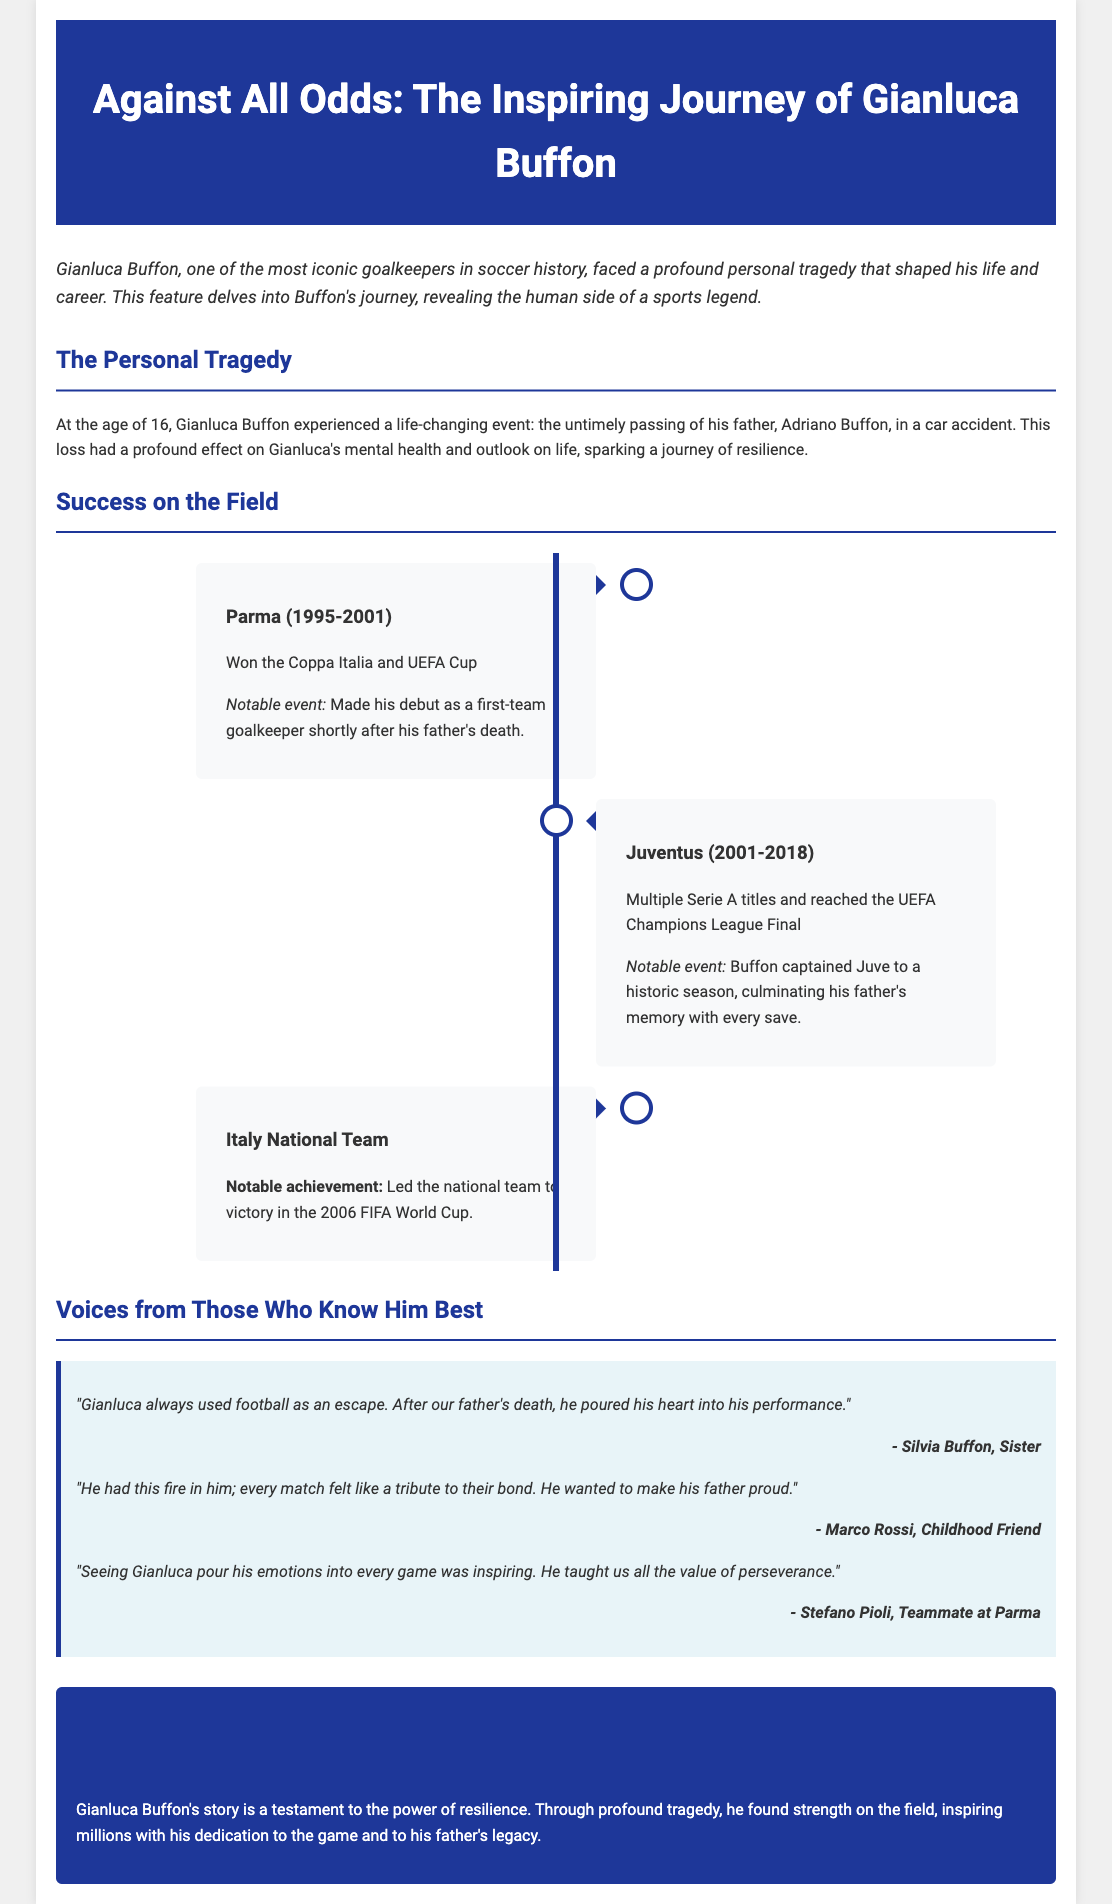what tragedy did Gianluca Buffon face at age 16? The document states that Gianluca Buffon experienced the untimely passing of his father in a car accident.
Answer: his father's death which teams did Gianluca Buffon play for mentioned in the document? The document lists Parma and Juventus as the two major teams where Gianluca played.
Answer: Parma and Juventus what notable achievement did Gianluca Buffon accomplish with the Italy National Team? The document highlights that Gianluca led the national team to victory in the 2006 FIFA World Cup.
Answer: victory in the 2006 FIFA World Cup who is Gianluca Buffon's sister? The document mentions Silvia Buffon as Gianluca's sister providing a quote about him.
Answer: Silvia Buffon what did Marco Rossi say about Gianluca's motivation in games? The document quotes Marco Rossi as saying that Gianluca wanted to make his father proud in every match.
Answer: make his father proud how long did Gianluca Buffon play for Juventus? The document states that he played for Juventus from 2001 to 2018, which is 17 years.
Answer: 17 years what is the title of this feature article? The document provides the title "Against All Odds: The Inspiring Journey of Gianluca Buffon."
Answer: Against All Odds: The Inspiring Journey of Gianluca Buffon what color is the header background in the document? The document describes the header background color as a deep blue (#1e3799).
Answer: blue what does the timeline illustrate about Gianluca Buffon's career? The timeline presents significant milestones in Buffon's career, showing his achievements in clubs and the national team.
Answer: significant milestones 